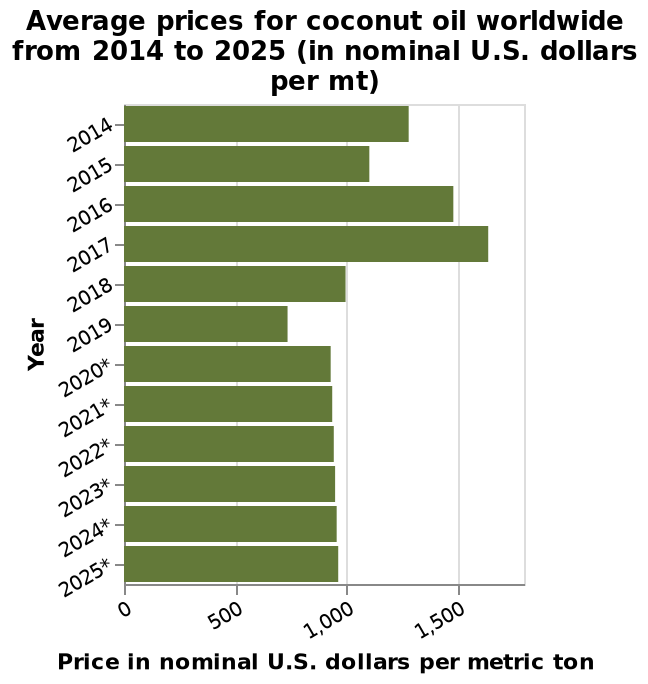<image>
Are the peak prices expected to occur again in the future?  The description does not provide information about the occurrence of peak prices in the future. What are the projected rates for 2020 to 2025?  The projected rates for 2020 to 2025 are due to remain constant. Describe the following image in detail This is a bar plot called Average prices for coconut oil worldwide from 2014 to 2025 (in nominal U.S. dollars per mt). On the x-axis, Price in nominal U.S. dollars per metric ton is defined. A categorical scale from 2014 to 2025* can be seen along the y-axis, labeled Year. What is the unit of measurement for the price data in the bar plot? The unit of measurement for the price data in the bar plot is nominal U.S. dollars per metric ton. 